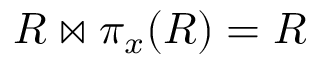<formula> <loc_0><loc_0><loc_500><loc_500>R \bowtie \pi _ { x } ( R ) = R</formula> 